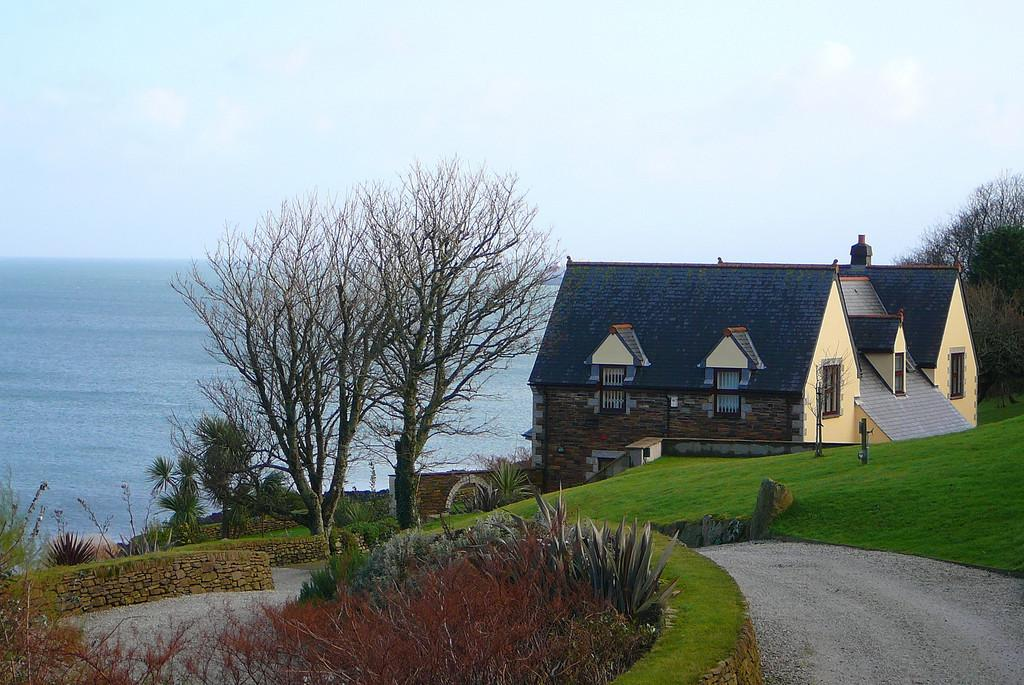What type of vegetation can be seen in the image? There is grass and plants visible in the image. What kind of path is present in the image? There is a path in the image. What structures can be seen in the image? There are walls and a house visible in the image. What other natural elements are present in the image? There are trees in the image. What man-made objects can be seen in the image? There are poles in the image. What can be seen in the background of the image? There is water and sky visible in the background of the image. What is the condition of the sky in the image? The sky has clouds in it. Can you hear the bell ringing in the image? There is no bell present in the image, so it cannot be heard. What emotion does the ear in the image express? There is no ear present in the image, so it cannot express any emotion. 